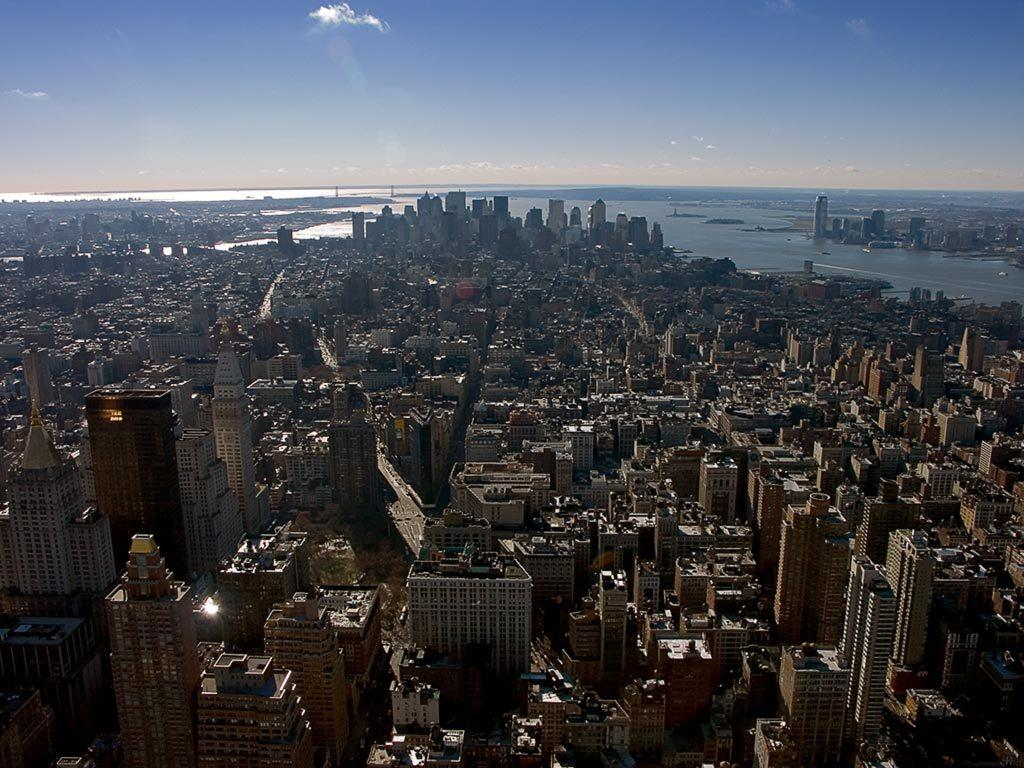What type of structures can be seen in the image? There are buildings in the image. What is present in the foreground of the image? There is a road in the image, and vehicles are on the road. What can be seen in the background of the image? There is water, buildings, and the sky visible in the background of the image. How much profit can be seen in the image? There is no mention of profit in the image, as it features buildings, a road, vehicles, water, and the sky. Can you tell me how many goldfish are swimming in the water in the image? There are no goldfish or snails present in the image; it features water, buildings, and the sky. 